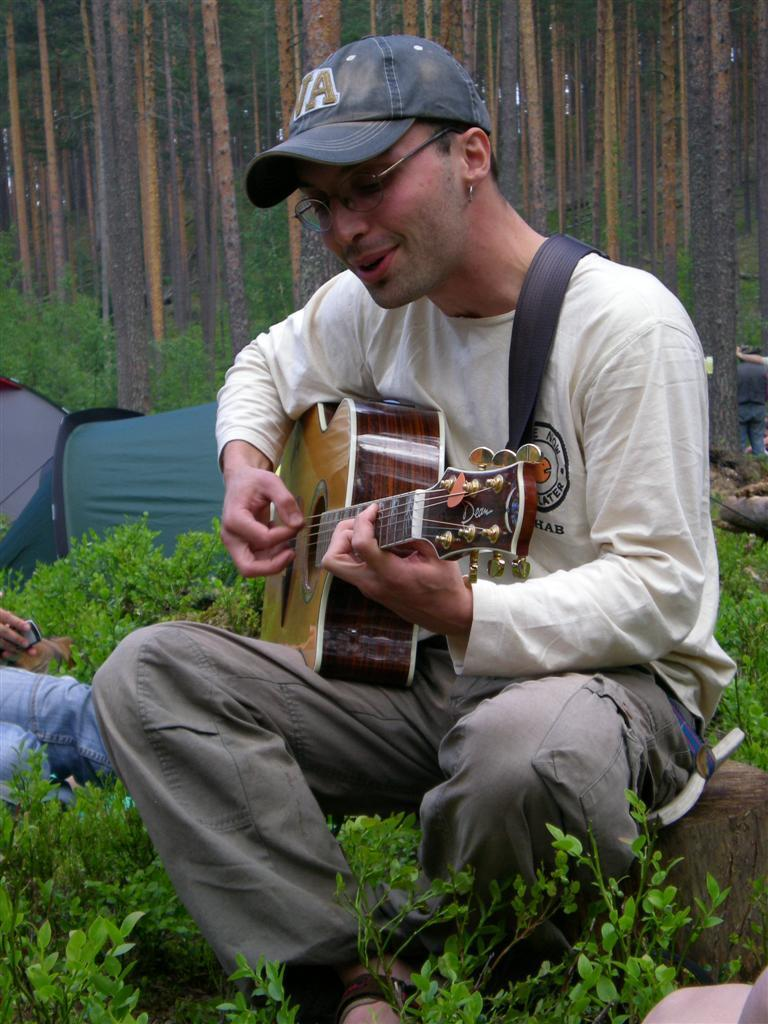What is the man in the image doing? The man is playing a guitar in the image. What accessories is the man wearing? The man is wearing spectacles and a cap. What can be seen in the background of the image? There are plants in the image. What type of fruit can be seen in the image? There is no fruit present in the image. 